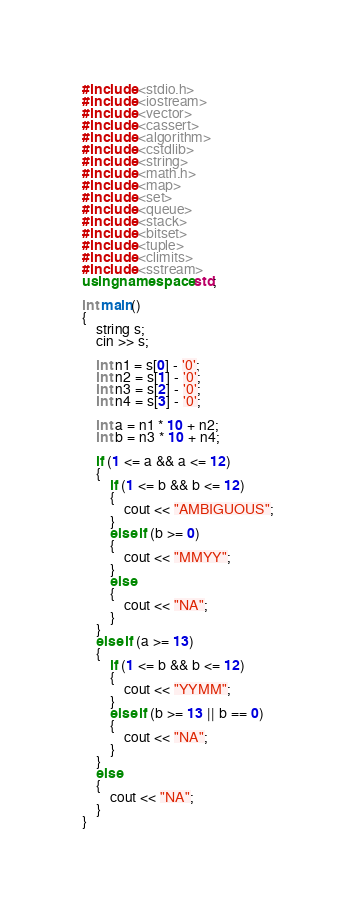<code> <loc_0><loc_0><loc_500><loc_500><_C++_>#include <stdio.h>
#include <iostream>
#include <vector>
#include <cassert>
#include <algorithm>
#include <cstdlib>
#include <string>
#include <math.h>
#include <map>
#include <set>
#include <queue>
#include <stack>
#include <bitset>
#include <tuple>
#include <climits>
#include <sstream>
using namespace std;

int main()
{
    string s;
    cin >> s;

    int n1 = s[0] - '0';
    int n2 = s[1] - '0';
    int n3 = s[2] - '0';
    int n4 = s[3] - '0';

    int a = n1 * 10 + n2;
    int b = n3 * 10 + n4;

    if (1 <= a && a <= 12)
    {
        if (1 <= b && b <= 12)
        {
            cout << "AMBIGUOUS";
        }
        else if (b >= 0)
        {
            cout << "MMYY";
        }
        else
        {
            cout << "NA";
        }
    }
    else if (a >= 13)
    {
        if (1 <= b && b <= 12)
        {
            cout << "YYMM";
        }
        else if (b >= 13 || b == 0)
        {
            cout << "NA";
        }
    }
    else
    {
        cout << "NA";
    }
}</code> 